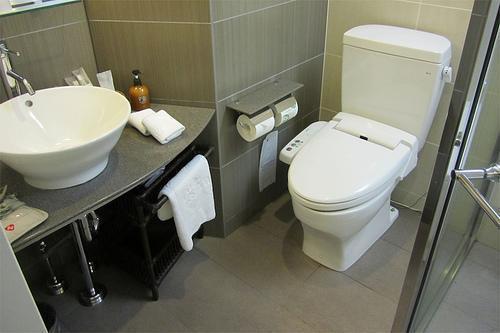How many bathrooms are in those photo?
Give a very brief answer. 1. 